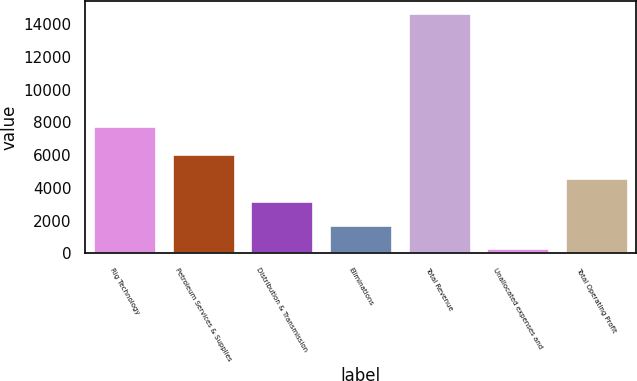Convert chart to OTSL. <chart><loc_0><loc_0><loc_500><loc_500><bar_chart><fcel>Rig Technology<fcel>Petroleum Services & Supplies<fcel>Distribution & Transmission<fcel>Eliminations<fcel>Total Revenue<fcel>Unallocated expenses and<fcel>Total Operating Profit<nl><fcel>7788<fcel>6057<fcel>3190<fcel>1756.5<fcel>14658<fcel>323<fcel>4623.5<nl></chart> 